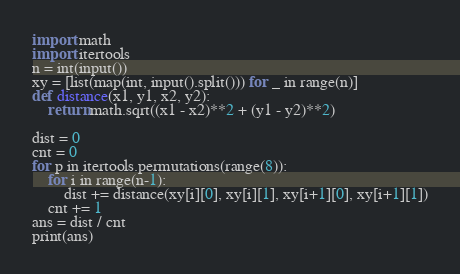Convert code to text. <code><loc_0><loc_0><loc_500><loc_500><_Python_>import math
import itertools
n = int(input())
xy = [list(map(int, input().split())) for _ in range(n)]
def distance(x1, y1, x2, y2):
    return math.sqrt((x1 - x2)**2 + (y1 - y2)**2)

dist = 0
cnt = 0
for p in itertools.permutations(range(8)):
    for i in range(n-1):
        dist += distance(xy[i][0], xy[i][1], xy[i+1][0], xy[i+1][1])
    cnt += 1
ans = dist / cnt
print(ans)
</code> 